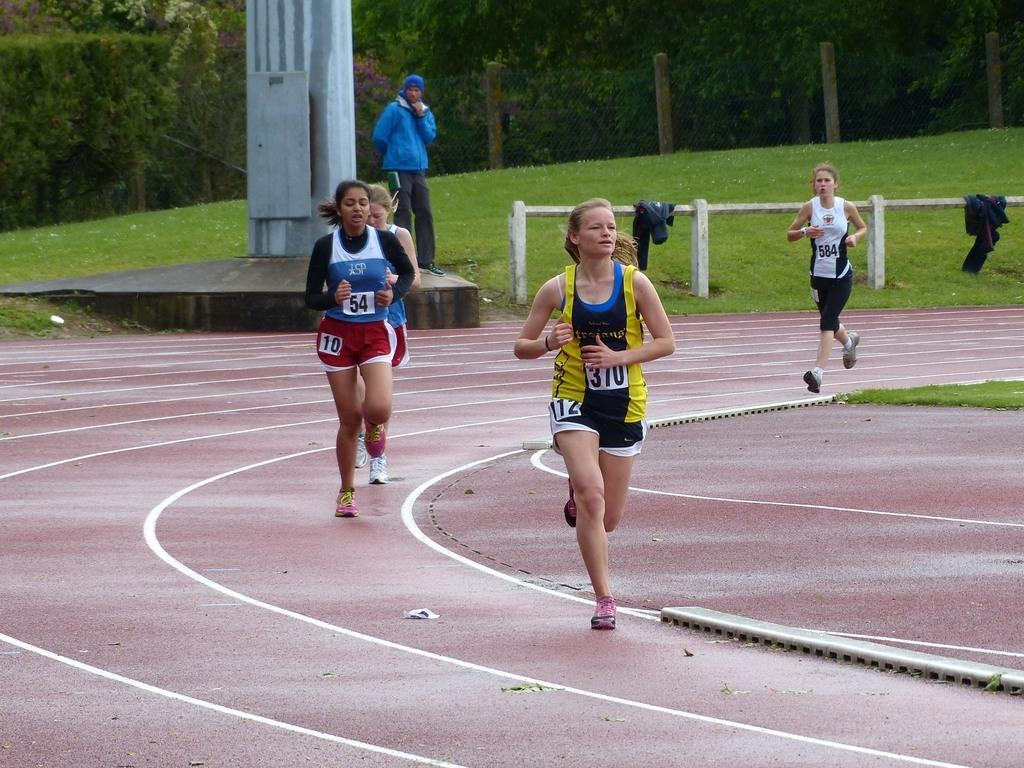What are the women in the image doing? The women are running in the image. What surface are the women running on? The women are running on the ground. What can be seen in the image besides the women running? There are fences, clothes, a pillar, a person standing, and trees in the background visible in the image. What language are the women speaking while running in the image? There is no indication of the women speaking in the image, so it cannot be determined what language they might be using. 